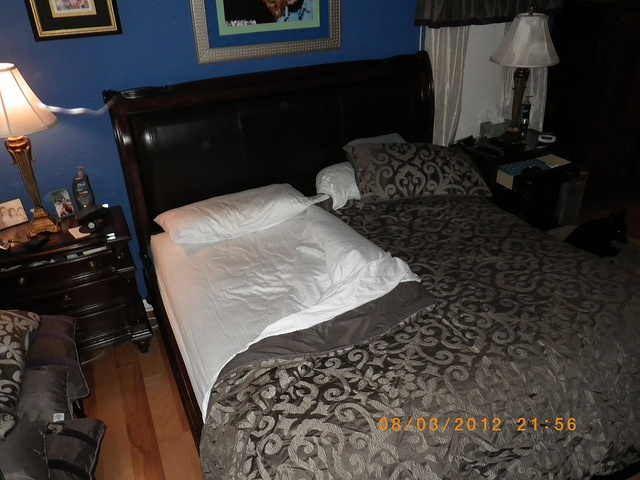Describe the objects in this image and their specific colors. I can see bed in darkblue, black, gray, and darkgray tones and clock in darkblue, gray, and black tones in this image. 